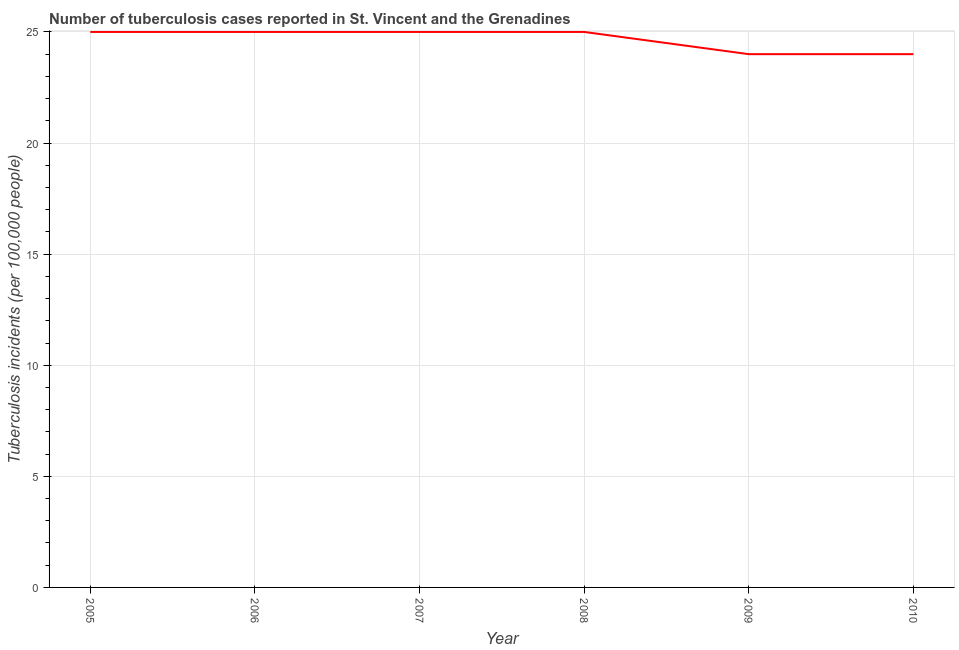What is the number of tuberculosis incidents in 2005?
Ensure brevity in your answer.  25. Across all years, what is the maximum number of tuberculosis incidents?
Your answer should be compact. 25. Across all years, what is the minimum number of tuberculosis incidents?
Ensure brevity in your answer.  24. In which year was the number of tuberculosis incidents maximum?
Provide a succinct answer. 2005. What is the sum of the number of tuberculosis incidents?
Make the answer very short. 148. What is the average number of tuberculosis incidents per year?
Provide a succinct answer. 24.67. What is the difference between the highest and the lowest number of tuberculosis incidents?
Provide a succinct answer. 1. Does the number of tuberculosis incidents monotonically increase over the years?
Offer a terse response. No. How many years are there in the graph?
Offer a terse response. 6. What is the difference between two consecutive major ticks on the Y-axis?
Give a very brief answer. 5. Are the values on the major ticks of Y-axis written in scientific E-notation?
Your answer should be compact. No. What is the title of the graph?
Provide a succinct answer. Number of tuberculosis cases reported in St. Vincent and the Grenadines. What is the label or title of the Y-axis?
Keep it short and to the point. Tuberculosis incidents (per 100,0 people). What is the Tuberculosis incidents (per 100,000 people) in 2006?
Offer a very short reply. 25. What is the Tuberculosis incidents (per 100,000 people) of 2010?
Ensure brevity in your answer.  24. What is the difference between the Tuberculosis incidents (per 100,000 people) in 2005 and 2008?
Provide a succinct answer. 0. What is the difference between the Tuberculosis incidents (per 100,000 people) in 2005 and 2009?
Your answer should be compact. 1. What is the difference between the Tuberculosis incidents (per 100,000 people) in 2005 and 2010?
Keep it short and to the point. 1. What is the difference between the Tuberculosis incidents (per 100,000 people) in 2006 and 2007?
Your answer should be very brief. 0. What is the difference between the Tuberculosis incidents (per 100,000 people) in 2007 and 2008?
Your answer should be compact. 0. What is the difference between the Tuberculosis incidents (per 100,000 people) in 2007 and 2009?
Ensure brevity in your answer.  1. What is the difference between the Tuberculosis incidents (per 100,000 people) in 2008 and 2010?
Provide a succinct answer. 1. What is the ratio of the Tuberculosis incidents (per 100,000 people) in 2005 to that in 2006?
Offer a very short reply. 1. What is the ratio of the Tuberculosis incidents (per 100,000 people) in 2005 to that in 2007?
Give a very brief answer. 1. What is the ratio of the Tuberculosis incidents (per 100,000 people) in 2005 to that in 2008?
Your answer should be compact. 1. What is the ratio of the Tuberculosis incidents (per 100,000 people) in 2005 to that in 2009?
Offer a very short reply. 1.04. What is the ratio of the Tuberculosis incidents (per 100,000 people) in 2005 to that in 2010?
Keep it short and to the point. 1.04. What is the ratio of the Tuberculosis incidents (per 100,000 people) in 2006 to that in 2007?
Make the answer very short. 1. What is the ratio of the Tuberculosis incidents (per 100,000 people) in 2006 to that in 2008?
Offer a very short reply. 1. What is the ratio of the Tuberculosis incidents (per 100,000 people) in 2006 to that in 2009?
Offer a terse response. 1.04. What is the ratio of the Tuberculosis incidents (per 100,000 people) in 2006 to that in 2010?
Your answer should be compact. 1.04. What is the ratio of the Tuberculosis incidents (per 100,000 people) in 2007 to that in 2008?
Give a very brief answer. 1. What is the ratio of the Tuberculosis incidents (per 100,000 people) in 2007 to that in 2009?
Offer a terse response. 1.04. What is the ratio of the Tuberculosis incidents (per 100,000 people) in 2007 to that in 2010?
Provide a short and direct response. 1.04. What is the ratio of the Tuberculosis incidents (per 100,000 people) in 2008 to that in 2009?
Offer a terse response. 1.04. What is the ratio of the Tuberculosis incidents (per 100,000 people) in 2008 to that in 2010?
Provide a short and direct response. 1.04. 